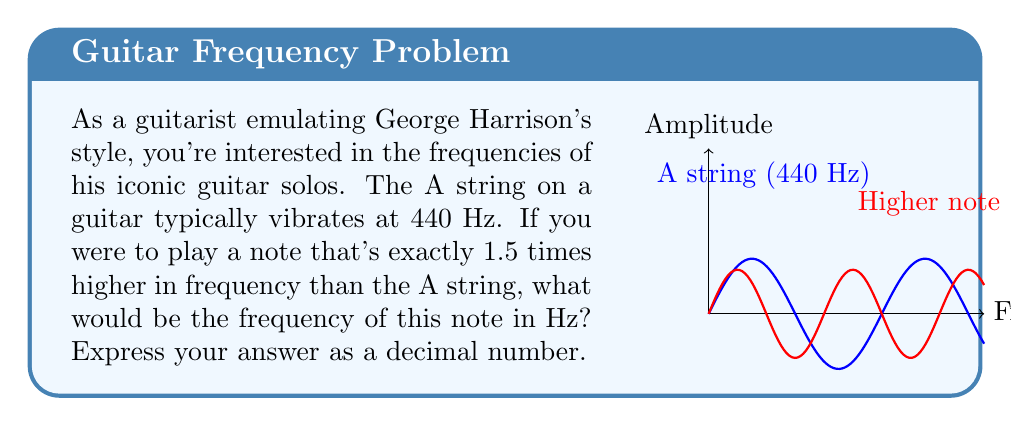Help me with this question. Let's approach this step-by-step:

1) We start with the frequency of the A string: 440 Hz

2) We're told that the new note is 1.5 times higher in frequency. This means we need to multiply 440 Hz by 1.5.

3) Let's set up the equation:
   
   $$f_{new} = 1.5 \times 440$$

4) Now, let's solve this equation:
   
   $$f_{new} = 1.5 \times 440 = 660$$

5) Therefore, the frequency of the new note is 660 Hz.

This note, by the way, is close to the E note on the 1st (high E) string of a guitar in standard tuning, which is typically around 659.25 Hz. This interval (from A to E) is a perfect fifth, commonly used in many of George Harrison's guitar solos.
Answer: 660 Hz 